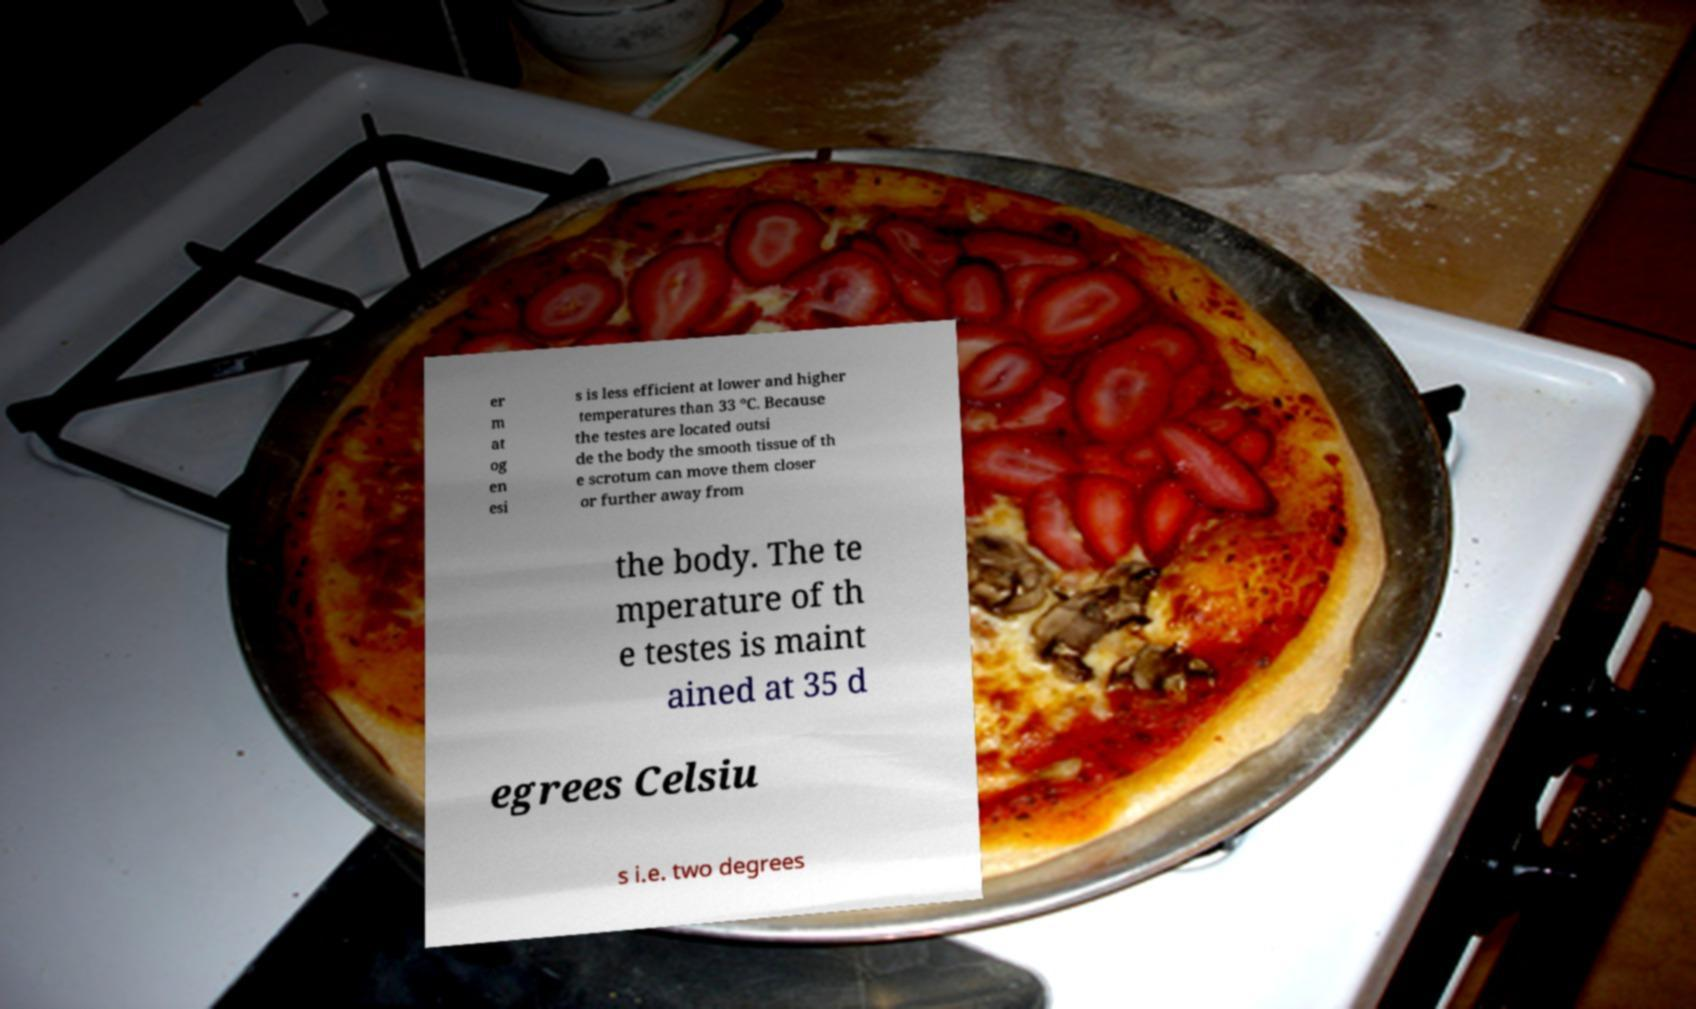Could you extract and type out the text from this image? er m at og en esi s is less efficient at lower and higher temperatures than 33 °C. Because the testes are located outsi de the body the smooth tissue of th e scrotum can move them closer or further away from the body. The te mperature of th e testes is maint ained at 35 d egrees Celsiu s i.e. two degrees 